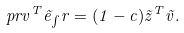Convert formula to latex. <formula><loc_0><loc_0><loc_500><loc_500>\ p r v ^ { T } \vec { e } _ { \int } r = ( 1 - c ) \vec { z } ^ { T } \vec { v } .</formula> 